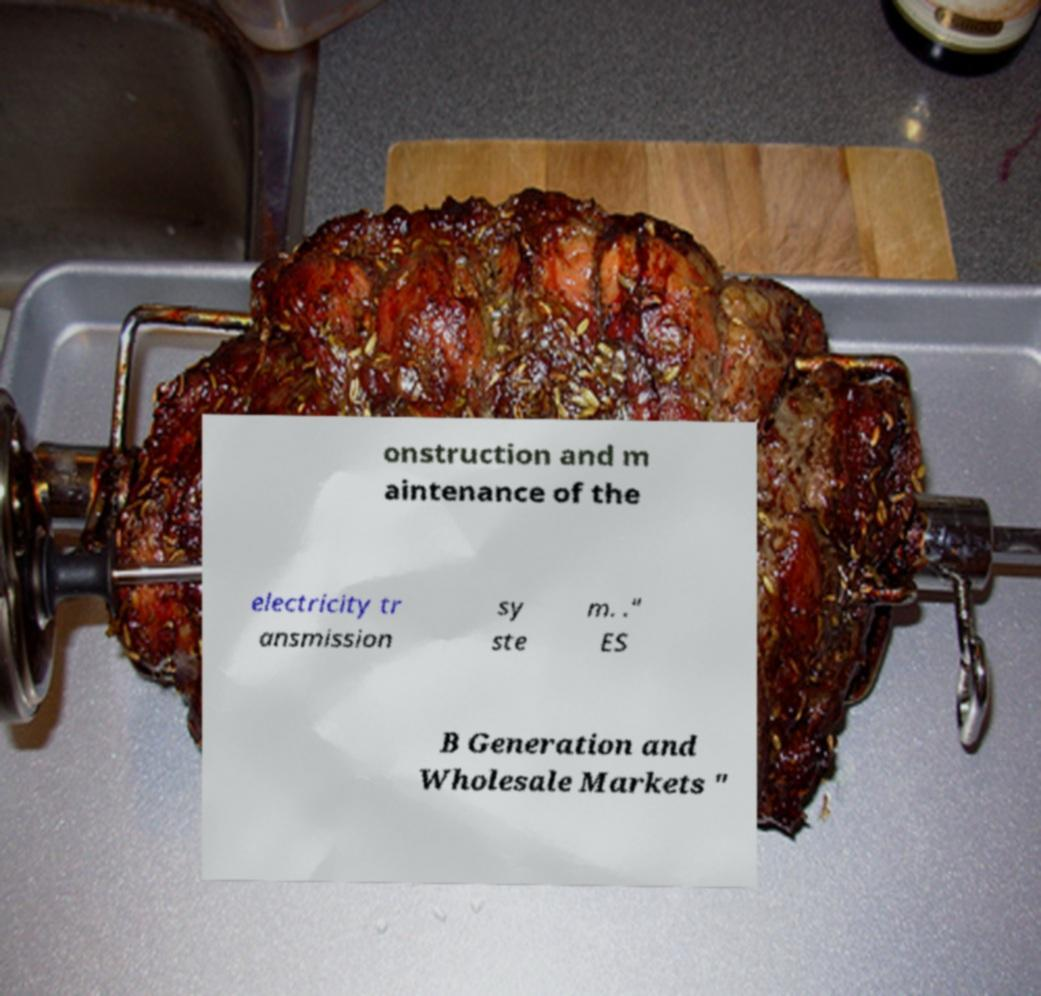Could you extract and type out the text from this image? onstruction and m aintenance of the electricity tr ansmission sy ste m. ." ES B Generation and Wholesale Markets " 